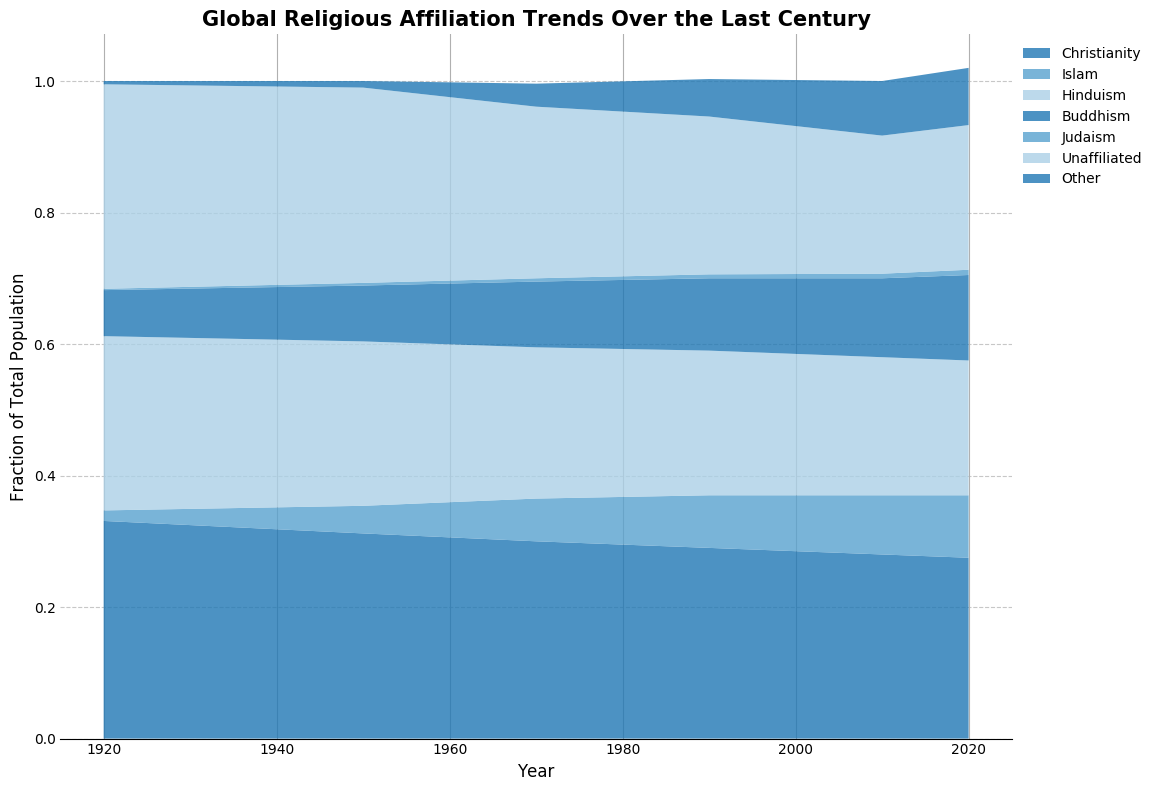What's the religion with the largest fraction of the global population in 2020? Looking at the stackplot for 2020, the area representing Christianity is the largest, indicating it has the largest fraction.
Answer: Christianity How did the fraction of the population that is unaffiliated change from 1920 to 2020? Compare the height of the 'Unaffiliated' area in the stackplot between 1920 and 2020, which shows an increase.
Answer: Increased Which religion showed the most significant growth in the global population fraction from 1920 to 2020? By examining the growth in area, Islam shows the most significant increase from a small fraction in 1920 to a much larger one in 2020.
Answer: Islam By how much did the fraction of the global population identifying as Christian decrease between 1950 and 2020? The fraction for Christianity can be seen to decrease from a larger area in 1950 to a smaller one in 2020.
Answer: Decreased In which period did the fraction of the global population identifying as Hinduism stay relatively constant? The fraction representing Hinduism's area remains fairly stable in size from 1920 through 2020.
Answer: 1920-2020 Which religion among Buddhism, Judaism, and Hinduism is the least in global population fraction as of 2020? By comparing the relative areas in 2020 for Buddhism, Judaism, and Hinduism, Judaism has the smallest area.
Answer: Judaism What notable change is seen in the fraction of unaffiliated and Christian populations from 2010 to 2020? The stackplot indicates that the unaffiliated population increased, while the Christian population decreased.
Answer: Unaffiliated increased, Christian decreased Between 1950 and 1990, which two religions had relatively stable fractions of the global population? The areas representing Buddhism and Hinduism remain relatively steady compared to others during this period.
Answer: Buddhism and Hinduism 